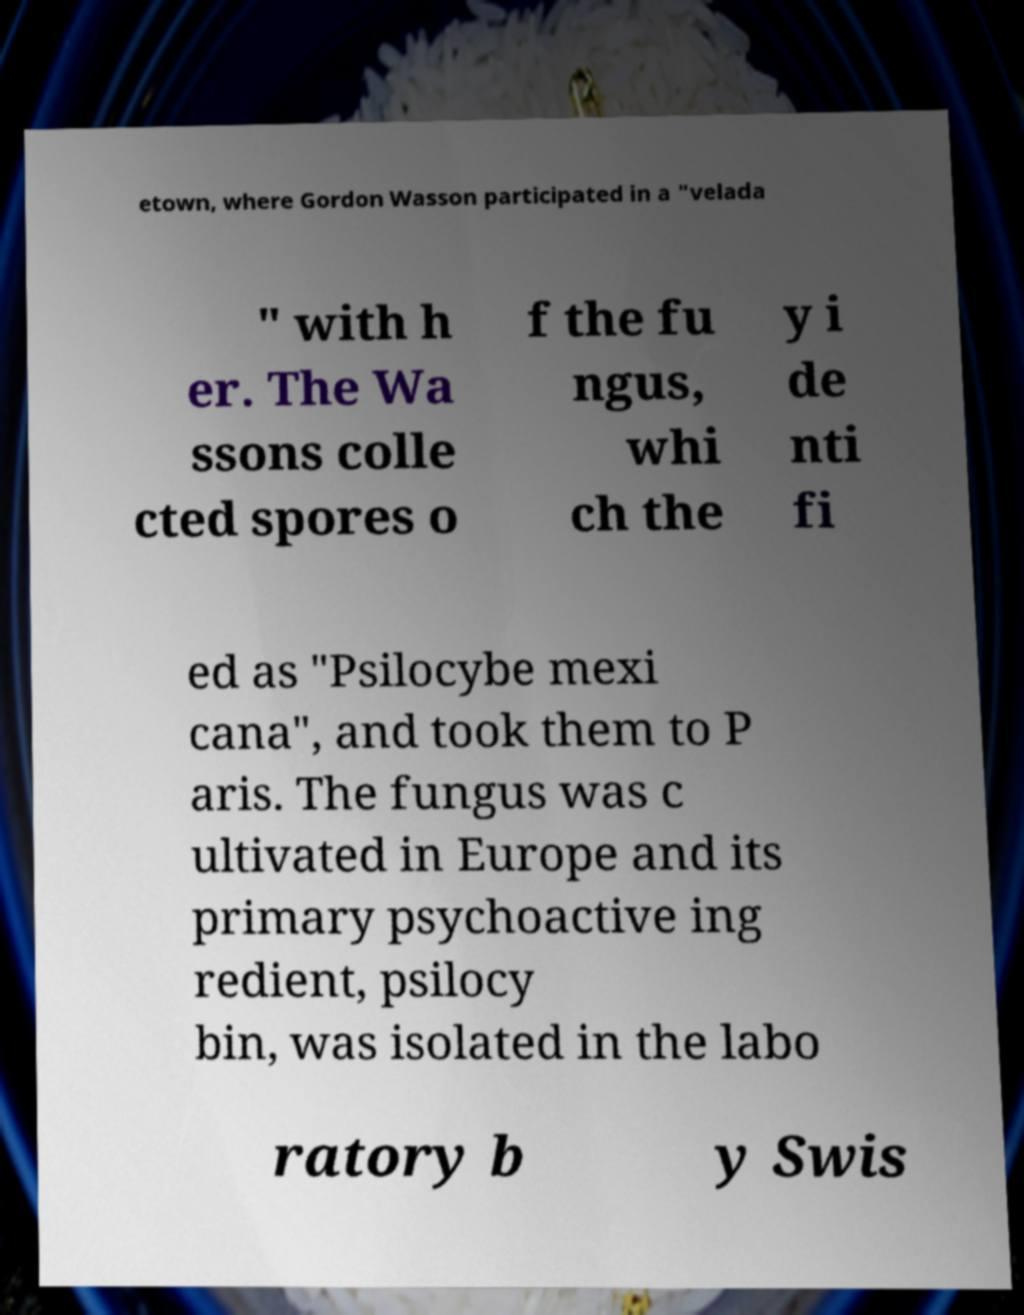There's text embedded in this image that I need extracted. Can you transcribe it verbatim? etown, where Gordon Wasson participated in a "velada " with h er. The Wa ssons colle cted spores o f the fu ngus, whi ch the y i de nti fi ed as "Psilocybe mexi cana", and took them to P aris. The fungus was c ultivated in Europe and its primary psychoactive ing redient, psilocy bin, was isolated in the labo ratory b y Swis 